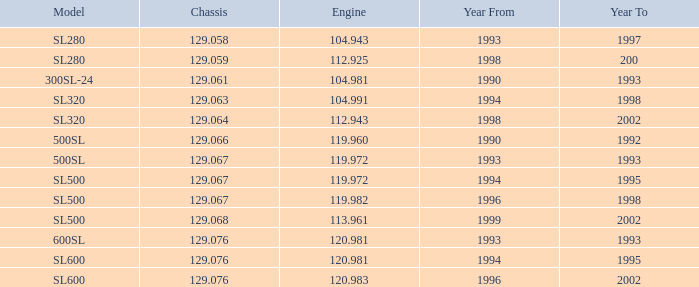What is the count of engines having a 1994 sl600 model and a year to earlier than 1995? 0.0. 